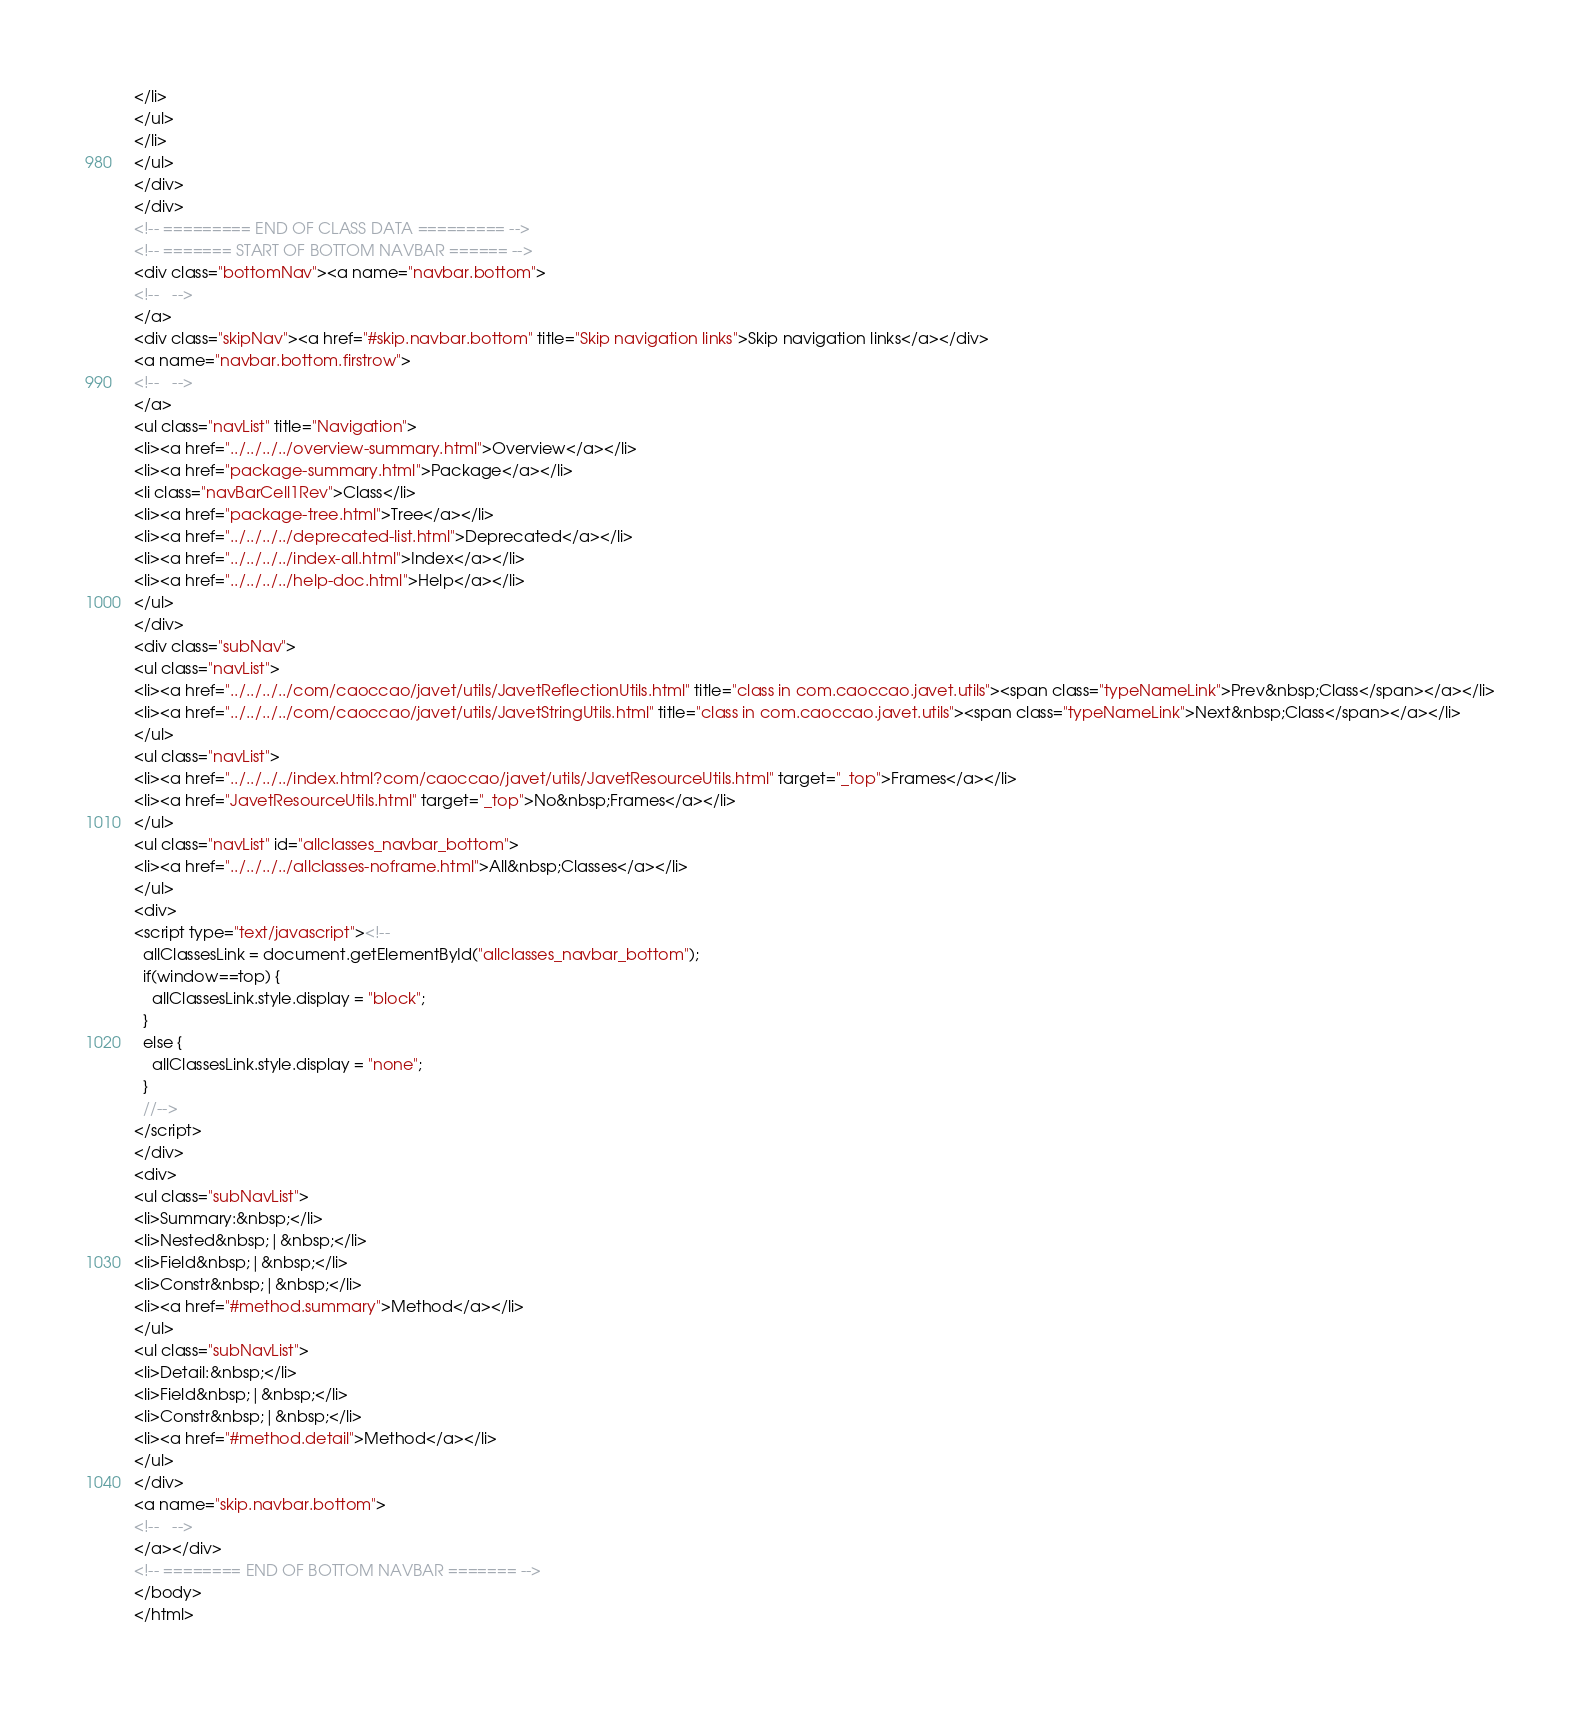<code> <loc_0><loc_0><loc_500><loc_500><_HTML_></li>
</ul>
</li>
</ul>
</div>
</div>
<!-- ========= END OF CLASS DATA ========= -->
<!-- ======= START OF BOTTOM NAVBAR ====== -->
<div class="bottomNav"><a name="navbar.bottom">
<!--   -->
</a>
<div class="skipNav"><a href="#skip.navbar.bottom" title="Skip navigation links">Skip navigation links</a></div>
<a name="navbar.bottom.firstrow">
<!--   -->
</a>
<ul class="navList" title="Navigation">
<li><a href="../../../../overview-summary.html">Overview</a></li>
<li><a href="package-summary.html">Package</a></li>
<li class="navBarCell1Rev">Class</li>
<li><a href="package-tree.html">Tree</a></li>
<li><a href="../../../../deprecated-list.html">Deprecated</a></li>
<li><a href="../../../../index-all.html">Index</a></li>
<li><a href="../../../../help-doc.html">Help</a></li>
</ul>
</div>
<div class="subNav">
<ul class="navList">
<li><a href="../../../../com/caoccao/javet/utils/JavetReflectionUtils.html" title="class in com.caoccao.javet.utils"><span class="typeNameLink">Prev&nbsp;Class</span></a></li>
<li><a href="../../../../com/caoccao/javet/utils/JavetStringUtils.html" title="class in com.caoccao.javet.utils"><span class="typeNameLink">Next&nbsp;Class</span></a></li>
</ul>
<ul class="navList">
<li><a href="../../../../index.html?com/caoccao/javet/utils/JavetResourceUtils.html" target="_top">Frames</a></li>
<li><a href="JavetResourceUtils.html" target="_top">No&nbsp;Frames</a></li>
</ul>
<ul class="navList" id="allclasses_navbar_bottom">
<li><a href="../../../../allclasses-noframe.html">All&nbsp;Classes</a></li>
</ul>
<div>
<script type="text/javascript"><!--
  allClassesLink = document.getElementById("allclasses_navbar_bottom");
  if(window==top) {
    allClassesLink.style.display = "block";
  }
  else {
    allClassesLink.style.display = "none";
  }
  //-->
</script>
</div>
<div>
<ul class="subNavList">
<li>Summary:&nbsp;</li>
<li>Nested&nbsp;|&nbsp;</li>
<li>Field&nbsp;|&nbsp;</li>
<li>Constr&nbsp;|&nbsp;</li>
<li><a href="#method.summary">Method</a></li>
</ul>
<ul class="subNavList">
<li>Detail:&nbsp;</li>
<li>Field&nbsp;|&nbsp;</li>
<li>Constr&nbsp;|&nbsp;</li>
<li><a href="#method.detail">Method</a></li>
</ul>
</div>
<a name="skip.navbar.bottom">
<!--   -->
</a></div>
<!-- ======== END OF BOTTOM NAVBAR ======= -->
</body>
</html>
</code> 